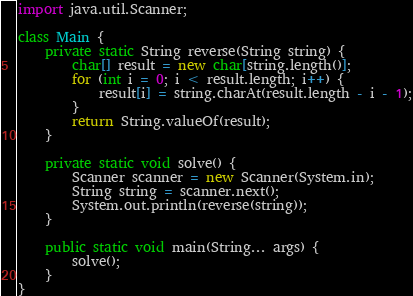Convert code to text. <code><loc_0><loc_0><loc_500><loc_500><_Java_>import java.util.Scanner;

class Main {
    private static String reverse(String string) {
        char[] result = new char[string.length()];
        for (int i = 0; i < result.length; i++) {
            result[i] = string.charAt(result.length - i - 1);
        }
        return String.valueOf(result);
    }

    private static void solve() {
        Scanner scanner = new Scanner(System.in);
        String string = scanner.next();
        System.out.println(reverse(string));
    }

    public static void main(String... args) {
        solve();
    }
}</code> 